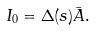<formula> <loc_0><loc_0><loc_500><loc_500>I _ { 0 } = \Delta ( s ) \bar { A } .</formula> 